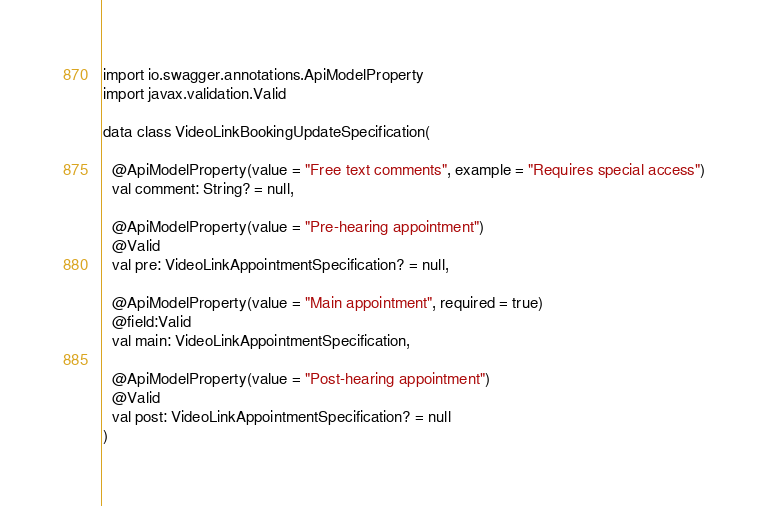Convert code to text. <code><loc_0><loc_0><loc_500><loc_500><_Kotlin_>import io.swagger.annotations.ApiModelProperty
import javax.validation.Valid

data class VideoLinkBookingUpdateSpecification(

  @ApiModelProperty(value = "Free text comments", example = "Requires special access")
  val comment: String? = null,

  @ApiModelProperty(value = "Pre-hearing appointment")
  @Valid
  val pre: VideoLinkAppointmentSpecification? = null,

  @ApiModelProperty(value = "Main appointment", required = true)
  @field:Valid
  val main: VideoLinkAppointmentSpecification,

  @ApiModelProperty(value = "Post-hearing appointment")
  @Valid
  val post: VideoLinkAppointmentSpecification? = null
)
</code> 